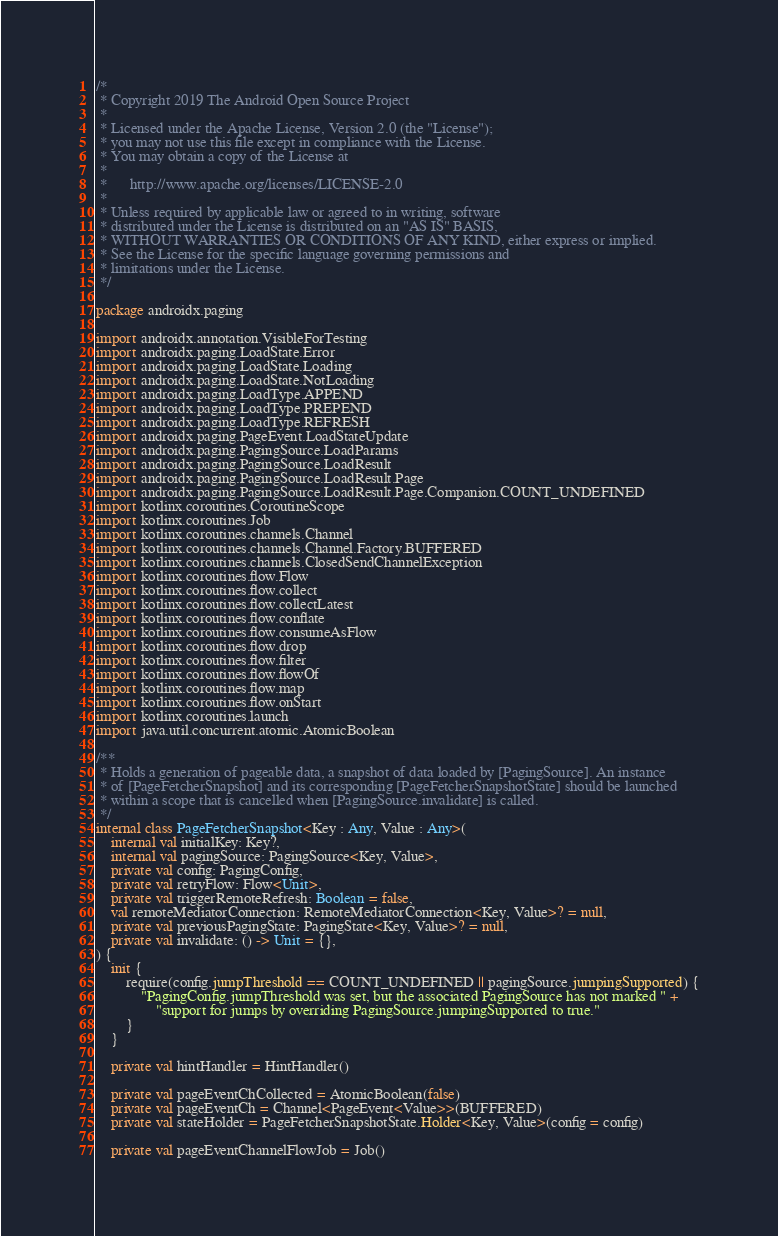<code> <loc_0><loc_0><loc_500><loc_500><_Kotlin_>/*
 * Copyright 2019 The Android Open Source Project
 *
 * Licensed under the Apache License, Version 2.0 (the "License");
 * you may not use this file except in compliance with the License.
 * You may obtain a copy of the License at
 *
 *      http://www.apache.org/licenses/LICENSE-2.0
 *
 * Unless required by applicable law or agreed to in writing, software
 * distributed under the License is distributed on an "AS IS" BASIS,
 * WITHOUT WARRANTIES OR CONDITIONS OF ANY KIND, either express or implied.
 * See the License for the specific language governing permissions and
 * limitations under the License.
 */

package androidx.paging

import androidx.annotation.VisibleForTesting
import androidx.paging.LoadState.Error
import androidx.paging.LoadState.Loading
import androidx.paging.LoadState.NotLoading
import androidx.paging.LoadType.APPEND
import androidx.paging.LoadType.PREPEND
import androidx.paging.LoadType.REFRESH
import androidx.paging.PageEvent.LoadStateUpdate
import androidx.paging.PagingSource.LoadParams
import androidx.paging.PagingSource.LoadResult
import androidx.paging.PagingSource.LoadResult.Page
import androidx.paging.PagingSource.LoadResult.Page.Companion.COUNT_UNDEFINED
import kotlinx.coroutines.CoroutineScope
import kotlinx.coroutines.Job
import kotlinx.coroutines.channels.Channel
import kotlinx.coroutines.channels.Channel.Factory.BUFFERED
import kotlinx.coroutines.channels.ClosedSendChannelException
import kotlinx.coroutines.flow.Flow
import kotlinx.coroutines.flow.collect
import kotlinx.coroutines.flow.collectLatest
import kotlinx.coroutines.flow.conflate
import kotlinx.coroutines.flow.consumeAsFlow
import kotlinx.coroutines.flow.drop
import kotlinx.coroutines.flow.filter
import kotlinx.coroutines.flow.flowOf
import kotlinx.coroutines.flow.map
import kotlinx.coroutines.flow.onStart
import kotlinx.coroutines.launch
import java.util.concurrent.atomic.AtomicBoolean

/**
 * Holds a generation of pageable data, a snapshot of data loaded by [PagingSource]. An instance
 * of [PageFetcherSnapshot] and its corresponding [PageFetcherSnapshotState] should be launched
 * within a scope that is cancelled when [PagingSource.invalidate] is called.
 */
internal class PageFetcherSnapshot<Key : Any, Value : Any>(
    internal val initialKey: Key?,
    internal val pagingSource: PagingSource<Key, Value>,
    private val config: PagingConfig,
    private val retryFlow: Flow<Unit>,
    private val triggerRemoteRefresh: Boolean = false,
    val remoteMediatorConnection: RemoteMediatorConnection<Key, Value>? = null,
    private val previousPagingState: PagingState<Key, Value>? = null,
    private val invalidate: () -> Unit = {},
) {
    init {
        require(config.jumpThreshold == COUNT_UNDEFINED || pagingSource.jumpingSupported) {
            "PagingConfig.jumpThreshold was set, but the associated PagingSource has not marked " +
                "support for jumps by overriding PagingSource.jumpingSupported to true."
        }
    }

    private val hintHandler = HintHandler()

    private val pageEventChCollected = AtomicBoolean(false)
    private val pageEventCh = Channel<PageEvent<Value>>(BUFFERED)
    private val stateHolder = PageFetcherSnapshotState.Holder<Key, Value>(config = config)

    private val pageEventChannelFlowJob = Job()
</code> 